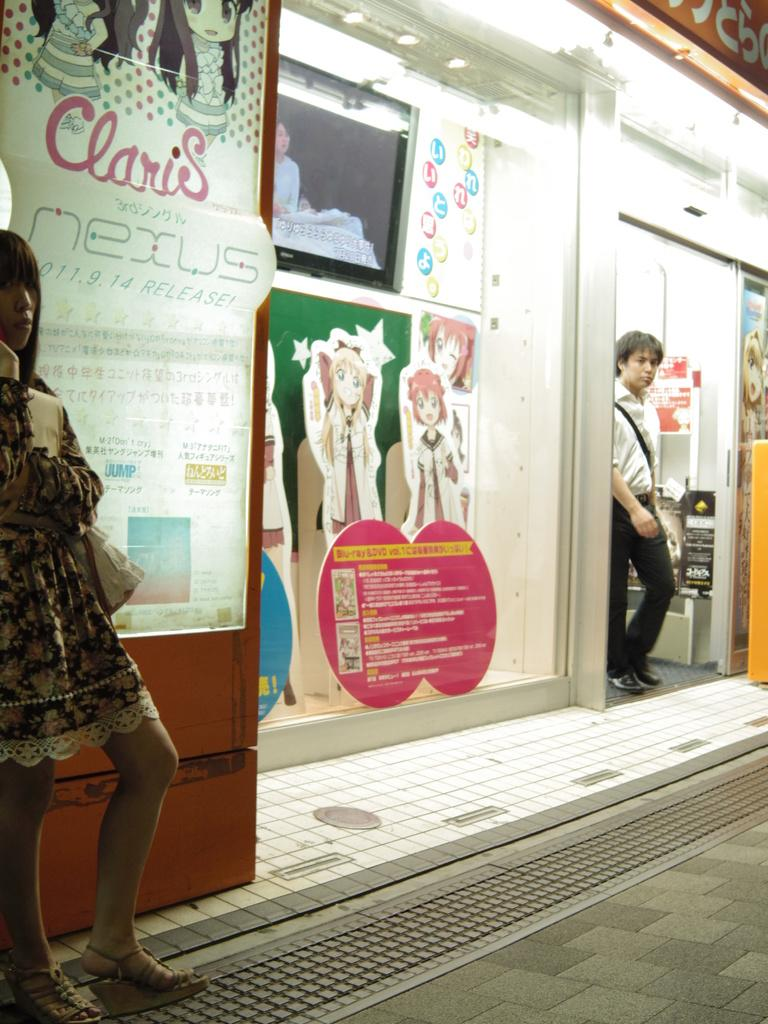Who or what can be seen in the image? There are people in the image. What is visible in the background of the image? There is a store in the background of the image, and boards are placed on the glass. What is at the bottom of the image? There is a road at the bottom of the image. Where is the door located in the image? There is a door on the right side of the image. Is there a fan visible in the image? No, there is no fan present in the image. Is it raining in the image? No, there is no indication of rain in the image. 